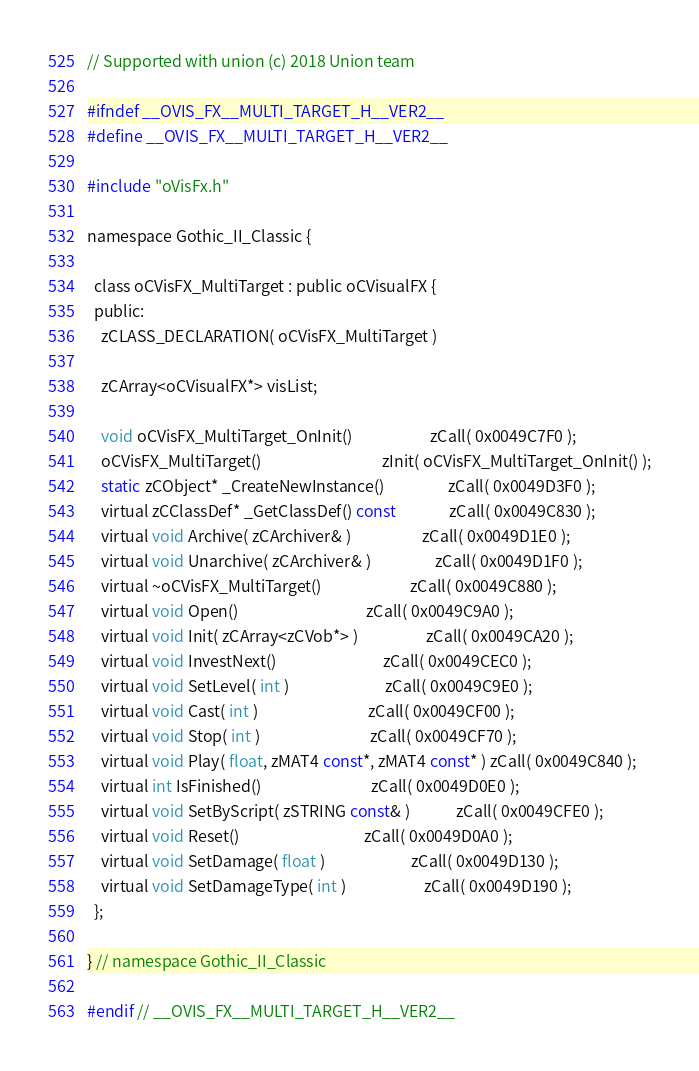<code> <loc_0><loc_0><loc_500><loc_500><_C_>// Supported with union (c) 2018 Union team

#ifndef __OVIS_FX__MULTI_TARGET_H__VER2__
#define __OVIS_FX__MULTI_TARGET_H__VER2__

#include "oVisFx.h"

namespace Gothic_II_Classic {

  class oCVisFX_MultiTarget : public oCVisualFX {
  public:
    zCLASS_DECLARATION( oCVisFX_MultiTarget )

    zCArray<oCVisualFX*> visList;

    void oCVisFX_MultiTarget_OnInit()                      zCall( 0x0049C7F0 );
    oCVisFX_MultiTarget()                                  zInit( oCVisFX_MultiTarget_OnInit() );
    static zCObject* _CreateNewInstance()                  zCall( 0x0049D3F0 );
    virtual zCClassDef* _GetClassDef() const               zCall( 0x0049C830 );
    virtual void Archive( zCArchiver& )                    zCall( 0x0049D1E0 );
    virtual void Unarchive( zCArchiver& )                  zCall( 0x0049D1F0 );
    virtual ~oCVisFX_MultiTarget()                         zCall( 0x0049C880 );
    virtual void Open()                                    zCall( 0x0049C9A0 );
    virtual void Init( zCArray<zCVob*> )                   zCall( 0x0049CA20 );
    virtual void InvestNext()                              zCall( 0x0049CEC0 );
    virtual void SetLevel( int )                           zCall( 0x0049C9E0 );
    virtual void Cast( int )                               zCall( 0x0049CF00 );
    virtual void Stop( int )                               zCall( 0x0049CF70 );
    virtual void Play( float, zMAT4 const*, zMAT4 const* ) zCall( 0x0049C840 );
    virtual int IsFinished()                               zCall( 0x0049D0E0 );
    virtual void SetByScript( zSTRING const& )             zCall( 0x0049CFE0 );
    virtual void Reset()                                   zCall( 0x0049D0A0 );
    virtual void SetDamage( float )                        zCall( 0x0049D130 );
    virtual void SetDamageType( int )                      zCall( 0x0049D190 );
  };

} // namespace Gothic_II_Classic

#endif // __OVIS_FX__MULTI_TARGET_H__VER2__</code> 